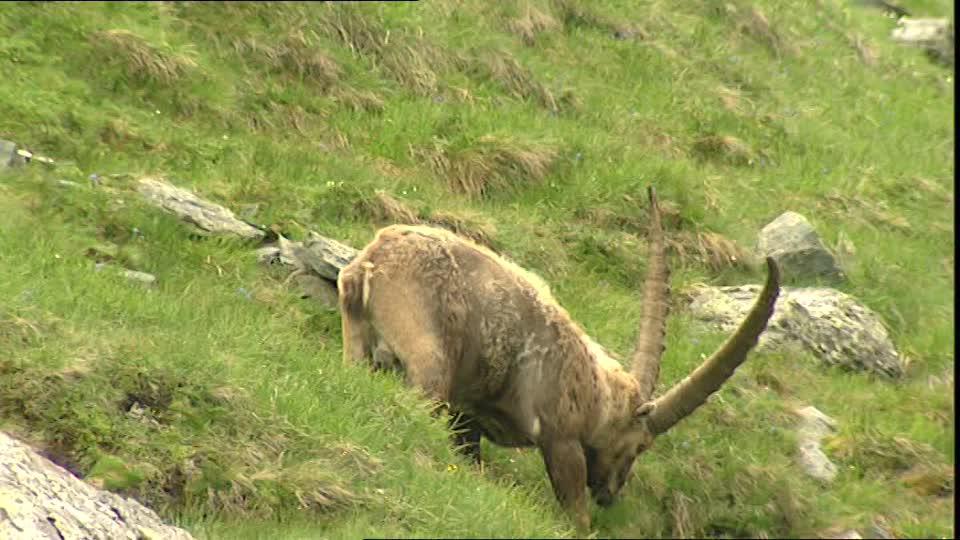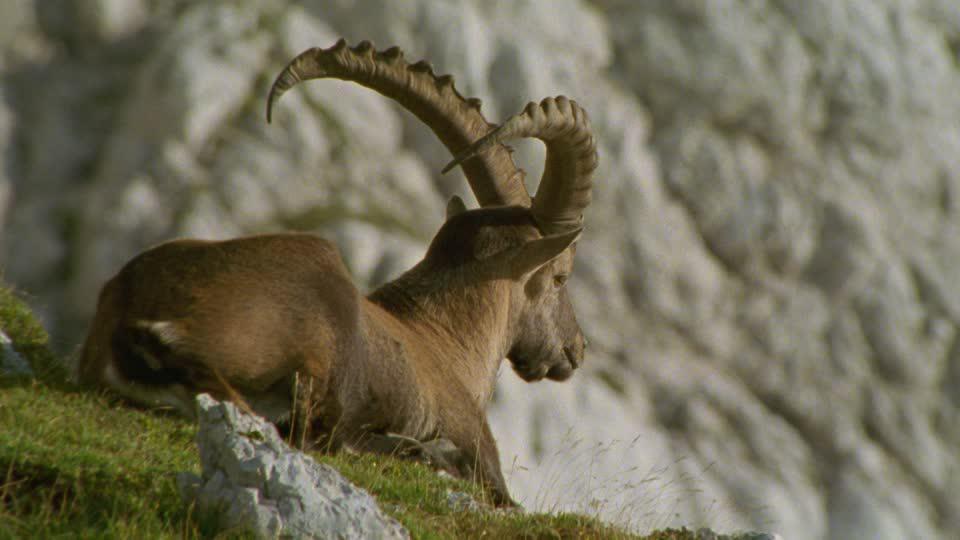The first image is the image on the left, the second image is the image on the right. Analyze the images presented: Is the assertion "An animal sits atop a rocky outcropping in the image on the right." valid? Answer yes or no. Yes. 